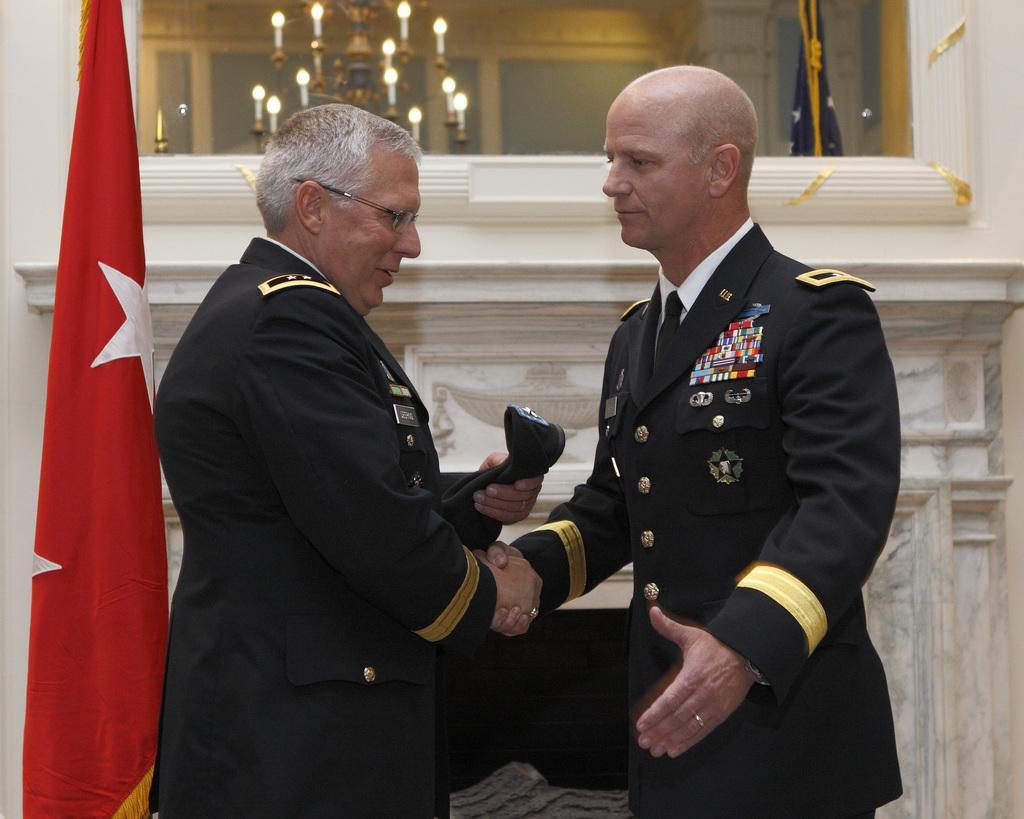In one or two sentences, can you explain what this image depicts? In this picture we can see two men are shaking hands and a man wore a spectacle and holding a cap with his hand and smiling and beside them we can see a flag and in the background we can see a chandelier, flag, mirror and some objects. 